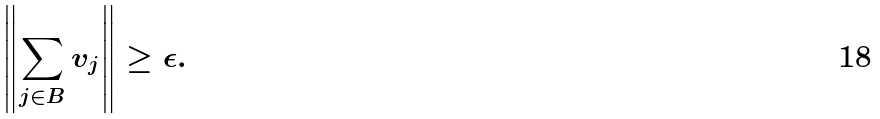<formula> <loc_0><loc_0><loc_500><loc_500>\left \| \sum _ { j \in B } v _ { j } \right \| \geq \epsilon .</formula> 